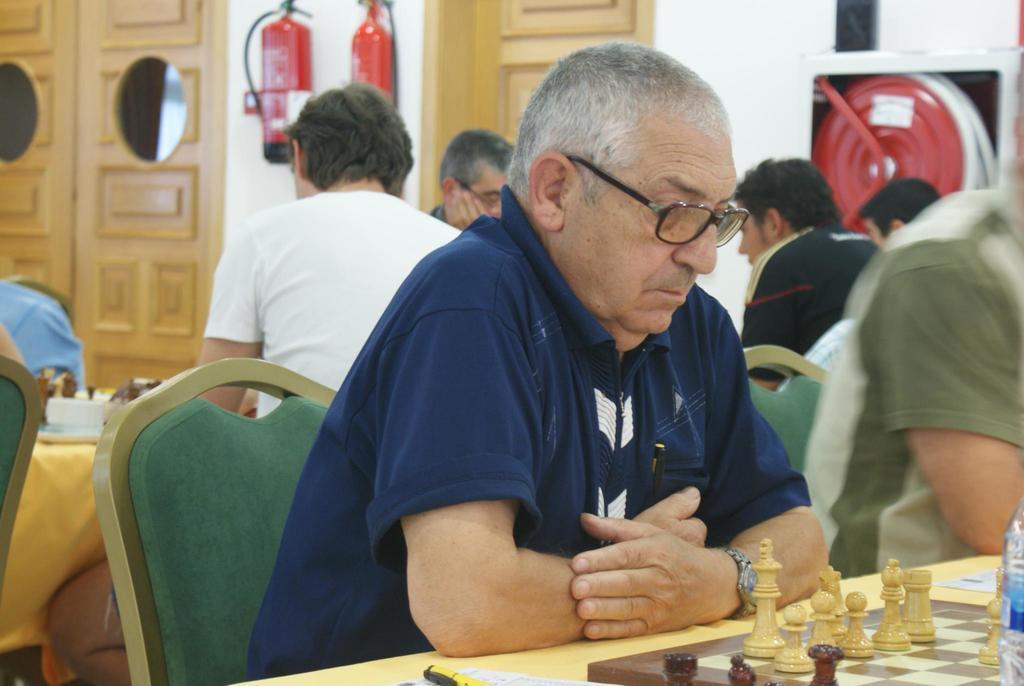Please provide a concise description of this image. In the image many people were playing chess by sitting in front of the tables and the chess boards were placed on the tables and in the background there are fire extinguishers and doors beside the wall. 